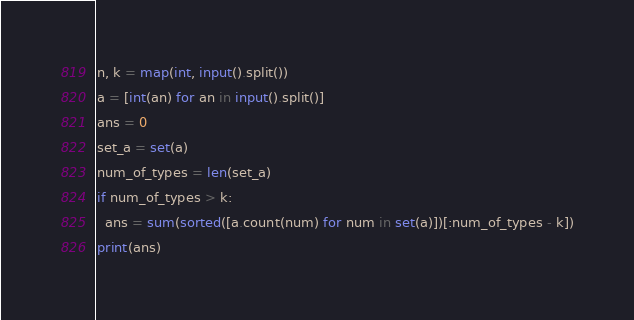<code> <loc_0><loc_0><loc_500><loc_500><_Python_>n, k = map(int, input().split())
a = [int(an) for an in input().split()]
ans = 0
set_a = set(a)
num_of_types = len(set_a)
if num_of_types > k:
  ans = sum(sorted([a.count(num) for num in set(a)])[:num_of_types - k])
print(ans)</code> 